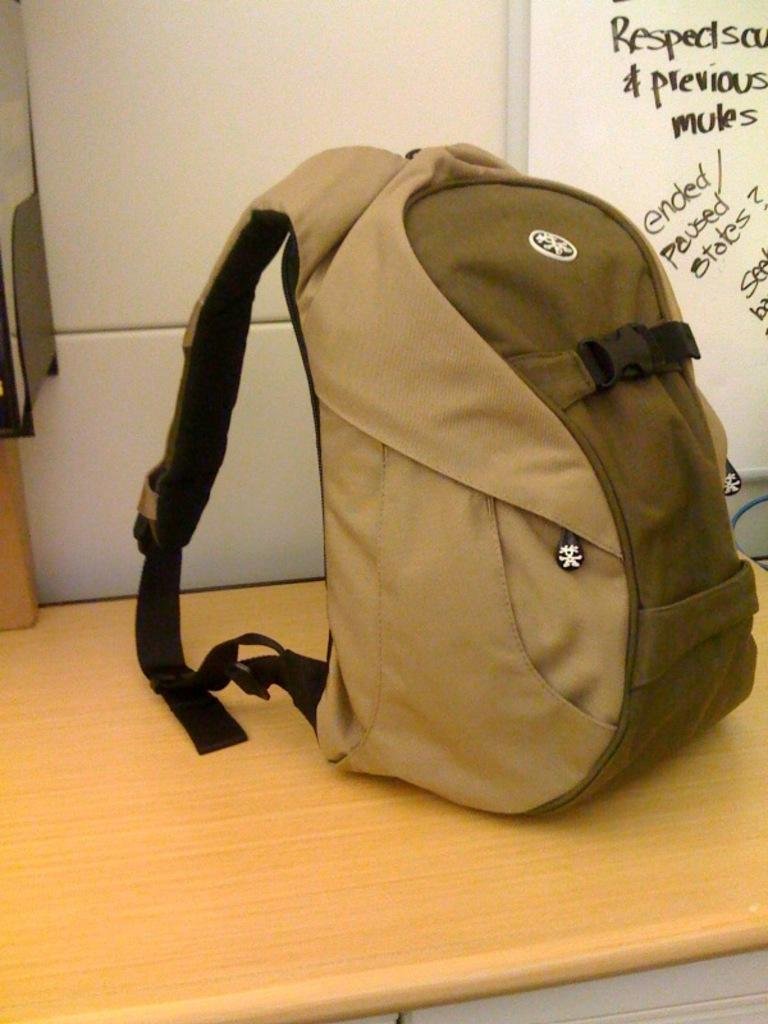<image>
Describe the image concisely. A backpack sits in front of whiteboard that says ended/paused states 